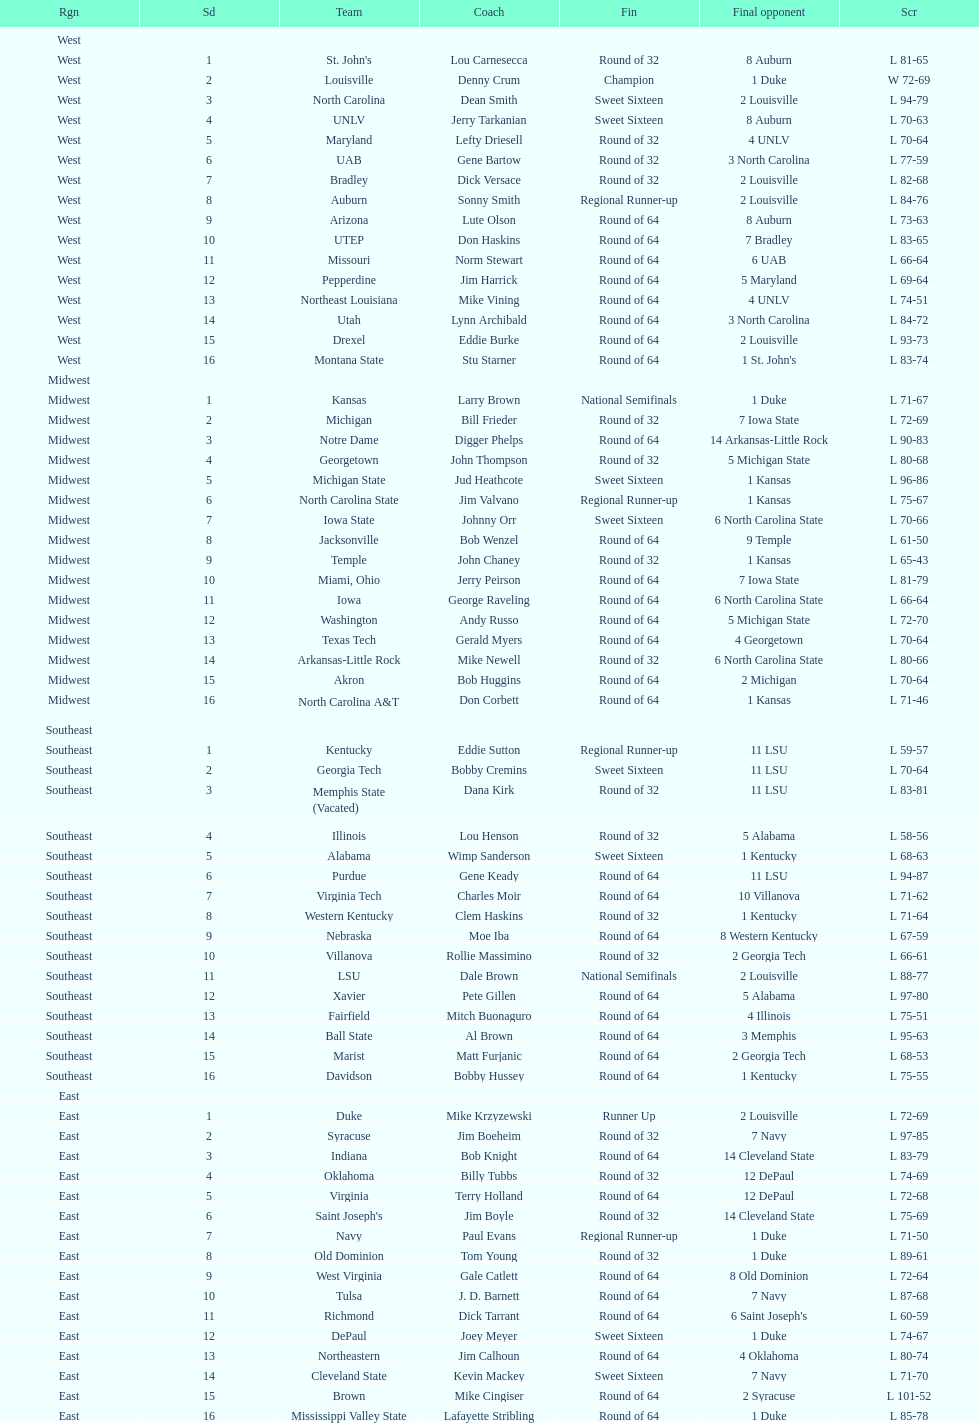Can you parse all the data within this table? {'header': ['Rgn', 'Sd', 'Team', 'Coach', 'Fin', 'Final opponent', 'Scr'], 'rows': [['West', '', '', '', '', '', ''], ['West', '1', "St. John's", 'Lou Carnesecca', 'Round of 32', '8 Auburn', 'L 81-65'], ['West', '2', 'Louisville', 'Denny Crum', 'Champion', '1 Duke', 'W 72-69'], ['West', '3', 'North Carolina', 'Dean Smith', 'Sweet Sixteen', '2 Louisville', 'L 94-79'], ['West', '4', 'UNLV', 'Jerry Tarkanian', 'Sweet Sixteen', '8 Auburn', 'L 70-63'], ['West', '5', 'Maryland', 'Lefty Driesell', 'Round of 32', '4 UNLV', 'L 70-64'], ['West', '6', 'UAB', 'Gene Bartow', 'Round of 32', '3 North Carolina', 'L 77-59'], ['West', '7', 'Bradley', 'Dick Versace', 'Round of 32', '2 Louisville', 'L 82-68'], ['West', '8', 'Auburn', 'Sonny Smith', 'Regional Runner-up', '2 Louisville', 'L 84-76'], ['West', '9', 'Arizona', 'Lute Olson', 'Round of 64', '8 Auburn', 'L 73-63'], ['West', '10', 'UTEP', 'Don Haskins', 'Round of 64', '7 Bradley', 'L 83-65'], ['West', '11', 'Missouri', 'Norm Stewart', 'Round of 64', '6 UAB', 'L 66-64'], ['West', '12', 'Pepperdine', 'Jim Harrick', 'Round of 64', '5 Maryland', 'L 69-64'], ['West', '13', 'Northeast Louisiana', 'Mike Vining', 'Round of 64', '4 UNLV', 'L 74-51'], ['West', '14', 'Utah', 'Lynn Archibald', 'Round of 64', '3 North Carolina', 'L 84-72'], ['West', '15', 'Drexel', 'Eddie Burke', 'Round of 64', '2 Louisville', 'L 93-73'], ['West', '16', 'Montana State', 'Stu Starner', 'Round of 64', "1 St. John's", 'L 83-74'], ['Midwest', '', '', '', '', '', ''], ['Midwest', '1', 'Kansas', 'Larry Brown', 'National Semifinals', '1 Duke', 'L 71-67'], ['Midwest', '2', 'Michigan', 'Bill Frieder', 'Round of 32', '7 Iowa State', 'L 72-69'], ['Midwest', '3', 'Notre Dame', 'Digger Phelps', 'Round of 64', '14 Arkansas-Little Rock', 'L 90-83'], ['Midwest', '4', 'Georgetown', 'John Thompson', 'Round of 32', '5 Michigan State', 'L 80-68'], ['Midwest', '5', 'Michigan State', 'Jud Heathcote', 'Sweet Sixteen', '1 Kansas', 'L 96-86'], ['Midwest', '6', 'North Carolina State', 'Jim Valvano', 'Regional Runner-up', '1 Kansas', 'L 75-67'], ['Midwest', '7', 'Iowa State', 'Johnny Orr', 'Sweet Sixteen', '6 North Carolina State', 'L 70-66'], ['Midwest', '8', 'Jacksonville', 'Bob Wenzel', 'Round of 64', '9 Temple', 'L 61-50'], ['Midwest', '9', 'Temple', 'John Chaney', 'Round of 32', '1 Kansas', 'L 65-43'], ['Midwest', '10', 'Miami, Ohio', 'Jerry Peirson', 'Round of 64', '7 Iowa State', 'L 81-79'], ['Midwest', '11', 'Iowa', 'George Raveling', 'Round of 64', '6 North Carolina State', 'L 66-64'], ['Midwest', '12', 'Washington', 'Andy Russo', 'Round of 64', '5 Michigan State', 'L 72-70'], ['Midwest', '13', 'Texas Tech', 'Gerald Myers', 'Round of 64', '4 Georgetown', 'L 70-64'], ['Midwest', '14', 'Arkansas-Little Rock', 'Mike Newell', 'Round of 32', '6 North Carolina State', 'L 80-66'], ['Midwest', '15', 'Akron', 'Bob Huggins', 'Round of 64', '2 Michigan', 'L 70-64'], ['Midwest', '16', 'North Carolina A&T', 'Don Corbett', 'Round of 64', '1 Kansas', 'L 71-46'], ['Southeast', '', '', '', '', '', ''], ['Southeast', '1', 'Kentucky', 'Eddie Sutton', 'Regional Runner-up', '11 LSU', 'L 59-57'], ['Southeast', '2', 'Georgia Tech', 'Bobby Cremins', 'Sweet Sixteen', '11 LSU', 'L 70-64'], ['Southeast', '3', 'Memphis State (Vacated)', 'Dana Kirk', 'Round of 32', '11 LSU', 'L 83-81'], ['Southeast', '4', 'Illinois', 'Lou Henson', 'Round of 32', '5 Alabama', 'L 58-56'], ['Southeast', '5', 'Alabama', 'Wimp Sanderson', 'Sweet Sixteen', '1 Kentucky', 'L 68-63'], ['Southeast', '6', 'Purdue', 'Gene Keady', 'Round of 64', '11 LSU', 'L 94-87'], ['Southeast', '7', 'Virginia Tech', 'Charles Moir', 'Round of 64', '10 Villanova', 'L 71-62'], ['Southeast', '8', 'Western Kentucky', 'Clem Haskins', 'Round of 32', '1 Kentucky', 'L 71-64'], ['Southeast', '9', 'Nebraska', 'Moe Iba', 'Round of 64', '8 Western Kentucky', 'L 67-59'], ['Southeast', '10', 'Villanova', 'Rollie Massimino', 'Round of 32', '2 Georgia Tech', 'L 66-61'], ['Southeast', '11', 'LSU', 'Dale Brown', 'National Semifinals', '2 Louisville', 'L 88-77'], ['Southeast', '12', 'Xavier', 'Pete Gillen', 'Round of 64', '5 Alabama', 'L 97-80'], ['Southeast', '13', 'Fairfield', 'Mitch Buonaguro', 'Round of 64', '4 Illinois', 'L 75-51'], ['Southeast', '14', 'Ball State', 'Al Brown', 'Round of 64', '3 Memphis', 'L 95-63'], ['Southeast', '15', 'Marist', 'Matt Furjanic', 'Round of 64', '2 Georgia Tech', 'L 68-53'], ['Southeast', '16', 'Davidson', 'Bobby Hussey', 'Round of 64', '1 Kentucky', 'L 75-55'], ['East', '', '', '', '', '', ''], ['East', '1', 'Duke', 'Mike Krzyzewski', 'Runner Up', '2 Louisville', 'L 72-69'], ['East', '2', 'Syracuse', 'Jim Boeheim', 'Round of 32', '7 Navy', 'L 97-85'], ['East', '3', 'Indiana', 'Bob Knight', 'Round of 64', '14 Cleveland State', 'L 83-79'], ['East', '4', 'Oklahoma', 'Billy Tubbs', 'Round of 32', '12 DePaul', 'L 74-69'], ['East', '5', 'Virginia', 'Terry Holland', 'Round of 64', '12 DePaul', 'L 72-68'], ['East', '6', "Saint Joseph's", 'Jim Boyle', 'Round of 32', '14 Cleveland State', 'L 75-69'], ['East', '7', 'Navy', 'Paul Evans', 'Regional Runner-up', '1 Duke', 'L 71-50'], ['East', '8', 'Old Dominion', 'Tom Young', 'Round of 32', '1 Duke', 'L 89-61'], ['East', '9', 'West Virginia', 'Gale Catlett', 'Round of 64', '8 Old Dominion', 'L 72-64'], ['East', '10', 'Tulsa', 'J. D. Barnett', 'Round of 64', '7 Navy', 'L 87-68'], ['East', '11', 'Richmond', 'Dick Tarrant', 'Round of 64', "6 Saint Joseph's", 'L 60-59'], ['East', '12', 'DePaul', 'Joey Meyer', 'Sweet Sixteen', '1 Duke', 'L 74-67'], ['East', '13', 'Northeastern', 'Jim Calhoun', 'Round of 64', '4 Oklahoma', 'L 80-74'], ['East', '14', 'Cleveland State', 'Kevin Mackey', 'Sweet Sixteen', '7 Navy', 'L 71-70'], ['East', '15', 'Brown', 'Mike Cingiser', 'Round of 64', '2 Syracuse', 'L 101-52'], ['East', '16', 'Mississippi Valley State', 'Lafayette Stribling', 'Round of 64', '1 Duke', 'L 85-78']]} Who is the only team from the east region to reach the final round? Duke. 